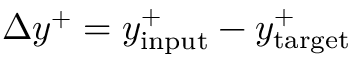Convert formula to latex. <formula><loc_0><loc_0><loc_500><loc_500>\Delta y ^ { + } = y _ { i n p u t } ^ { + } - y _ { t \arg e t } ^ { + }</formula> 